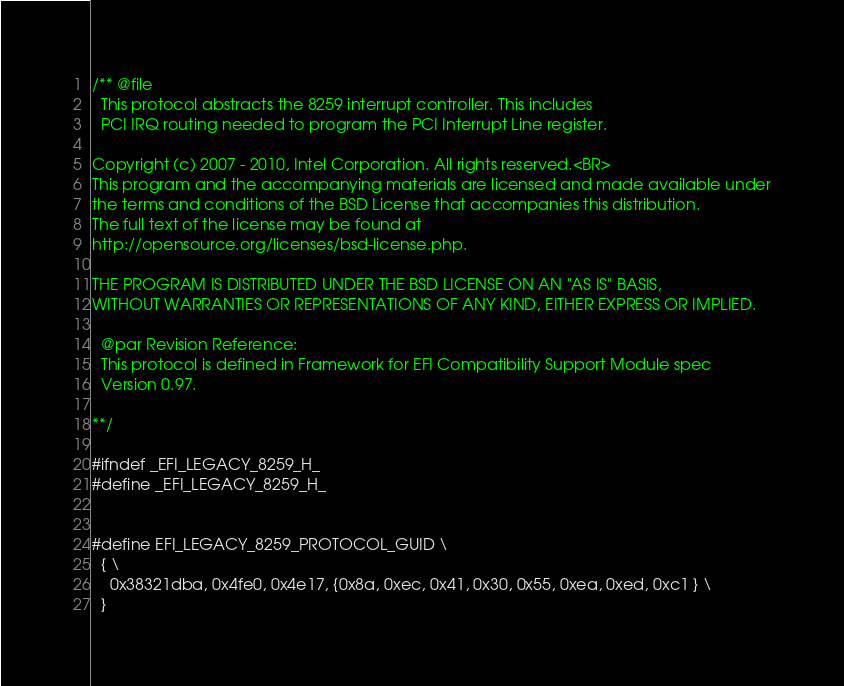Convert code to text. <code><loc_0><loc_0><loc_500><loc_500><_C_>/** @file
  This protocol abstracts the 8259 interrupt controller. This includes
  PCI IRQ routing needed to program the PCI Interrupt Line register.

Copyright (c) 2007 - 2010, Intel Corporation. All rights reserved.<BR>
This program and the accompanying materials are licensed and made available under
the terms and conditions of the BSD License that accompanies this distribution.
The full text of the license may be found at
http://opensource.org/licenses/bsd-license.php.

THE PROGRAM IS DISTRIBUTED UNDER THE BSD LICENSE ON AN "AS IS" BASIS,
WITHOUT WARRANTIES OR REPRESENTATIONS OF ANY KIND, EITHER EXPRESS OR IMPLIED.

  @par Revision Reference:
  This protocol is defined in Framework for EFI Compatibility Support Module spec
  Version 0.97.

**/

#ifndef _EFI_LEGACY_8259_H_
#define _EFI_LEGACY_8259_H_


#define EFI_LEGACY_8259_PROTOCOL_GUID \
  { \
    0x38321dba, 0x4fe0, 0x4e17, {0x8a, 0xec, 0x41, 0x30, 0x55, 0xea, 0xed, 0xc1 } \
  }
</code> 